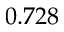<formula> <loc_0><loc_0><loc_500><loc_500>0 . 7 2 8</formula> 